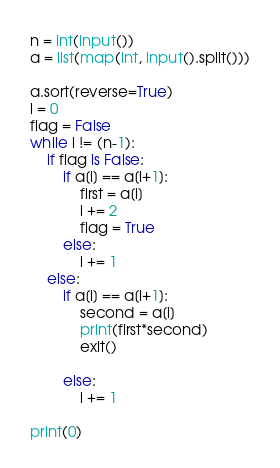<code> <loc_0><loc_0><loc_500><loc_500><_Python_>n = int(input())
a = list(map(int, input().split()))

a.sort(reverse=True)
i = 0
flag = False
while i != (n-1):
    if flag is False:
        if a[i] == a[i+1]:
            first = a[i]
            i += 2
            flag = True
        else:
            i += 1
    else:
        if a[i] == a[i+1]:
            second = a[i]
            print(first*second)
            exit()

        else:
            i += 1

print(0)


</code> 